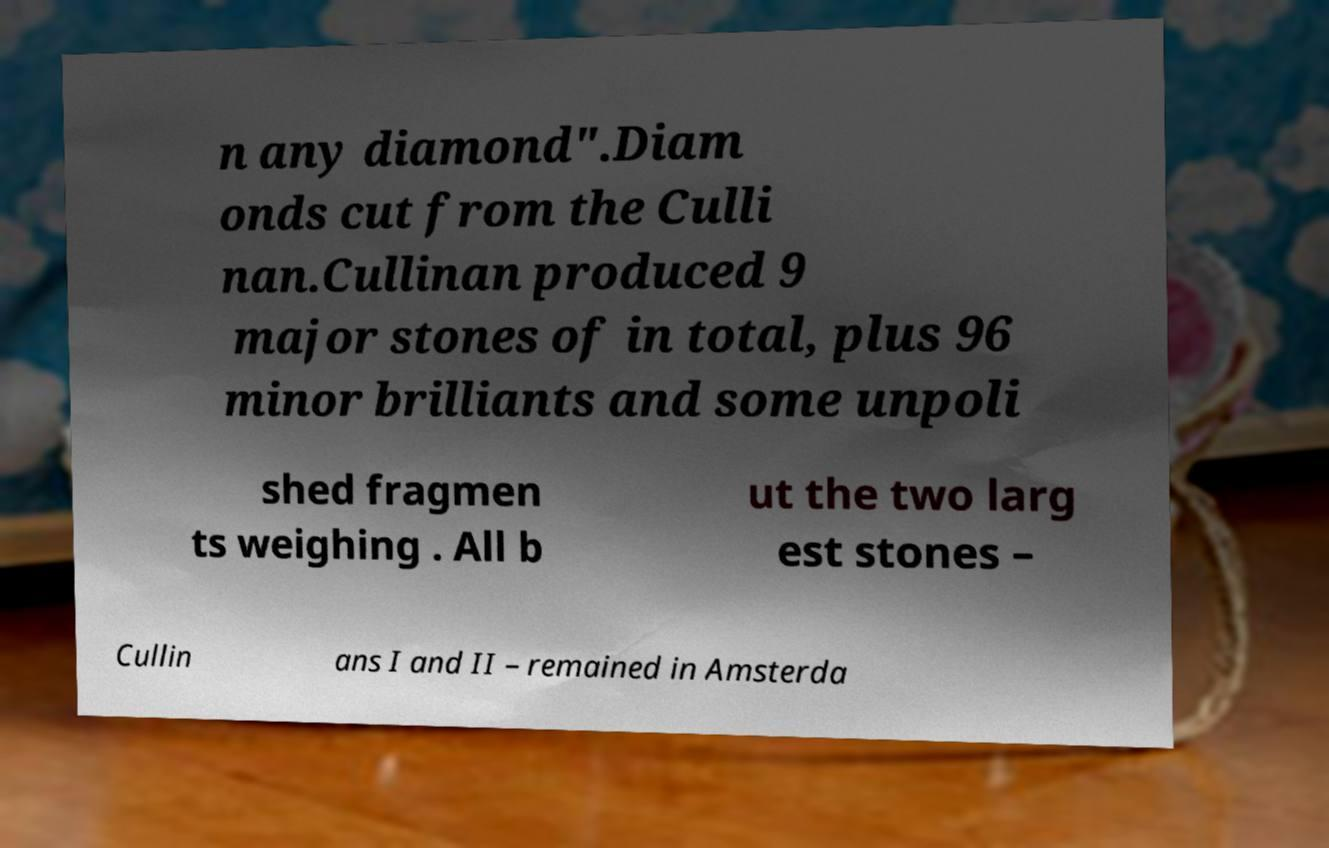Could you extract and type out the text from this image? n any diamond".Diam onds cut from the Culli nan.Cullinan produced 9 major stones of in total, plus 96 minor brilliants and some unpoli shed fragmen ts weighing . All b ut the two larg est stones – Cullin ans I and II – remained in Amsterda 